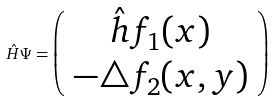<formula> <loc_0><loc_0><loc_500><loc_500>\hat { H } \Psi = \left ( \begin{array} { c } \hat { h } f _ { 1 } ( x ) \\ - \triangle f _ { 2 } ( x , y ) \\ \end{array} \right )</formula> 